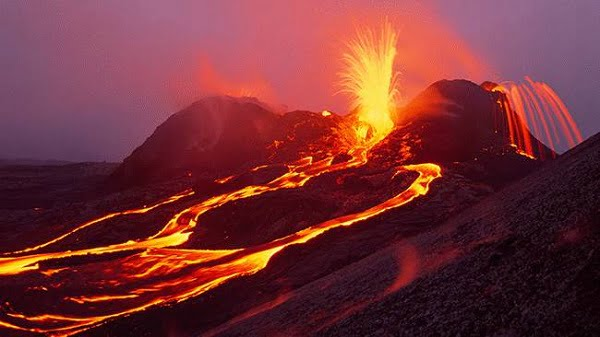Could you illustrate the various formations lava can create as seen in this image? Certainly, this image depicts several classic lava formations. The bright fountains spewing skyward are a result of gas pressure and can form spatter cones if the ejected material falls back and accumulates around the vent. The fluid, rope-like formations on the sides of the volcano are pahoehoe lava, which has a smooth, billowy surface. A'a flows might also be present—these are rough, blocky lava that cools into jagged chunks. Additionally, the glowing rivulets may eventually cool into solid tubes or channels, which can serve as pathways for lava travel during prolonged eruptions. 